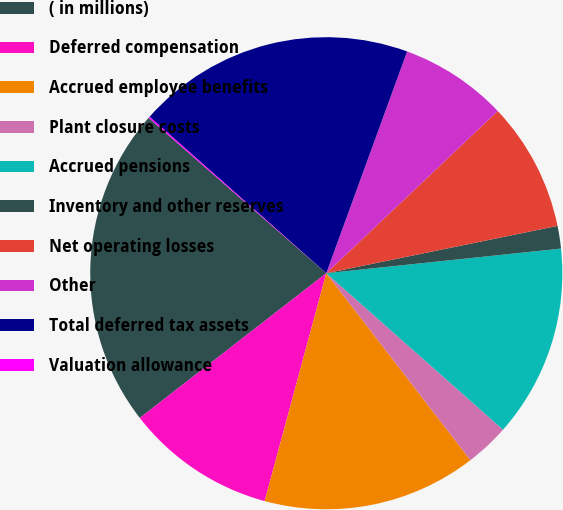Convert chart. <chart><loc_0><loc_0><loc_500><loc_500><pie_chart><fcel>( in millions)<fcel>Deferred compensation<fcel>Accrued employee benefits<fcel>Plant closure costs<fcel>Accrued pensions<fcel>Inventory and other reserves<fcel>Net operating losses<fcel>Other<fcel>Total deferred tax assets<fcel>Valuation allowance<nl><fcel>21.94%<fcel>10.29%<fcel>14.66%<fcel>3.01%<fcel>13.2%<fcel>1.55%<fcel>8.84%<fcel>7.38%<fcel>19.03%<fcel>0.1%<nl></chart> 